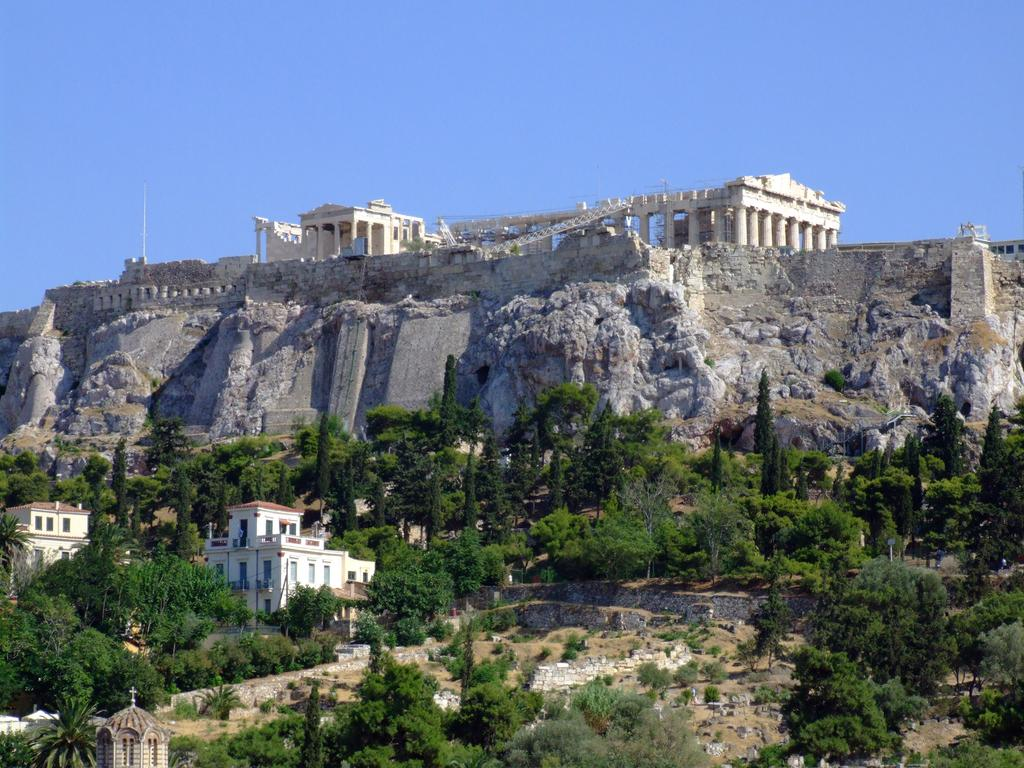What type of structure is in the image? There is a fort in the image. What type of natural elements are present in the image? Rocks and trees are present in the image. What type of human-made structures are present at the bottom of the image? There are houses at the bottom of the image. What religious symbol is visible at the bottom of the image? A holy cross is visible at the bottom of the image. What is visible at the top of the image? The sky is visible at the top of the image. Where is the sofa located in the image? There is no sofa present in the image. What type of flower can be seen growing near the fort in the image? There are no flowers visible in the image. 